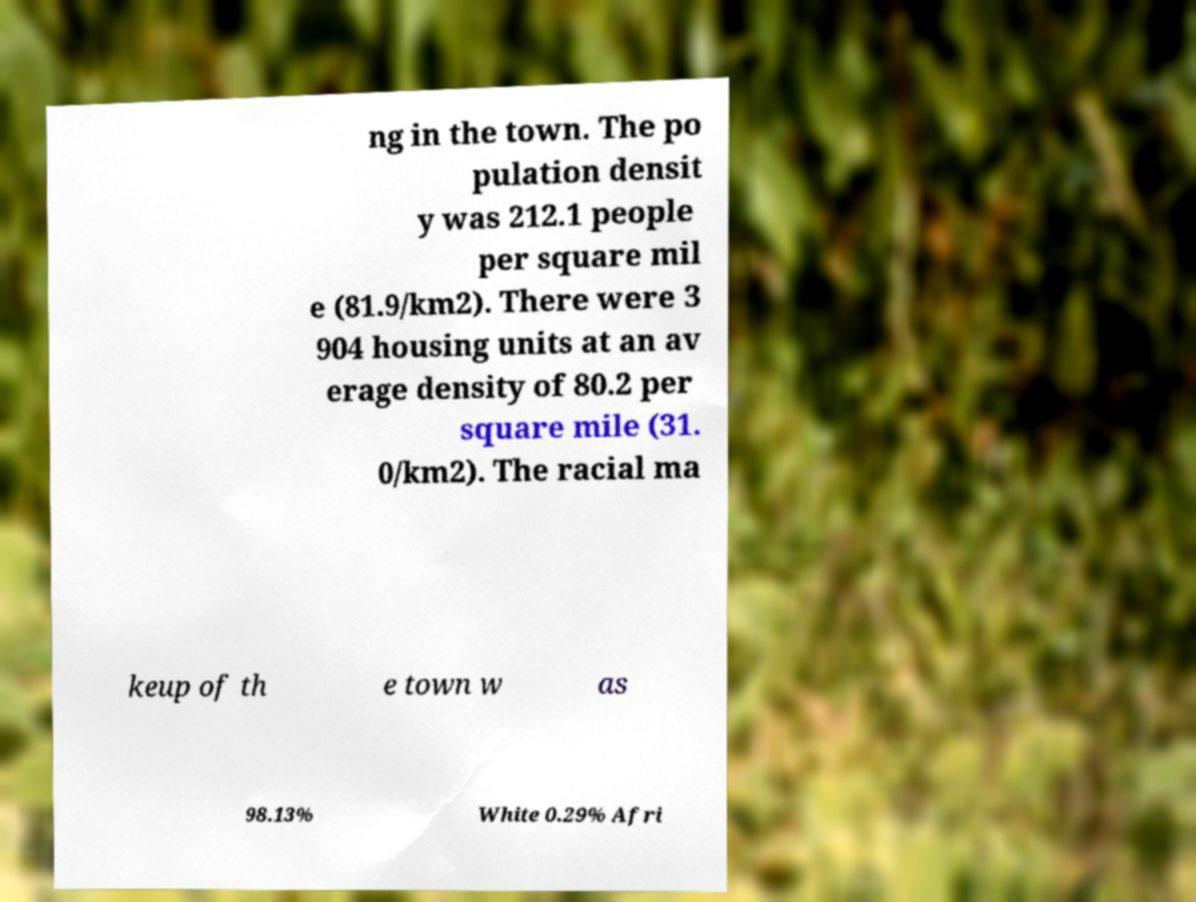I need the written content from this picture converted into text. Can you do that? ng in the town. The po pulation densit y was 212.1 people per square mil e (81.9/km2). There were 3 904 housing units at an av erage density of 80.2 per square mile (31. 0/km2). The racial ma keup of th e town w as 98.13% White 0.29% Afri 